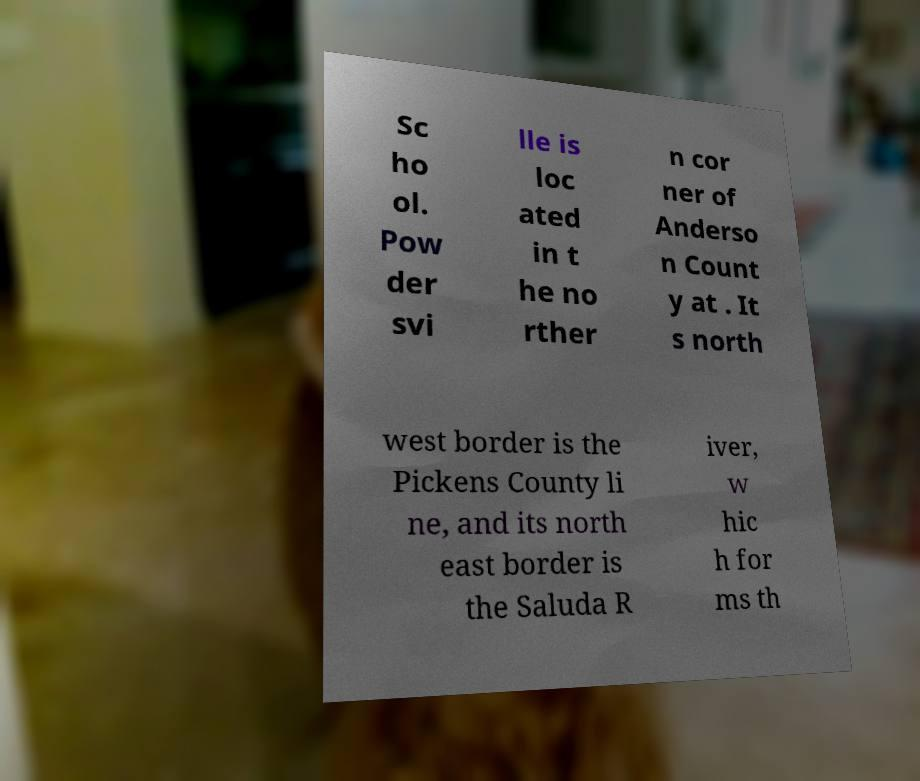For documentation purposes, I need the text within this image transcribed. Could you provide that? Sc ho ol. Pow der svi lle is loc ated in t he no rther n cor ner of Anderso n Count y at . It s north west border is the Pickens County li ne, and its north east border is the Saluda R iver, w hic h for ms th 